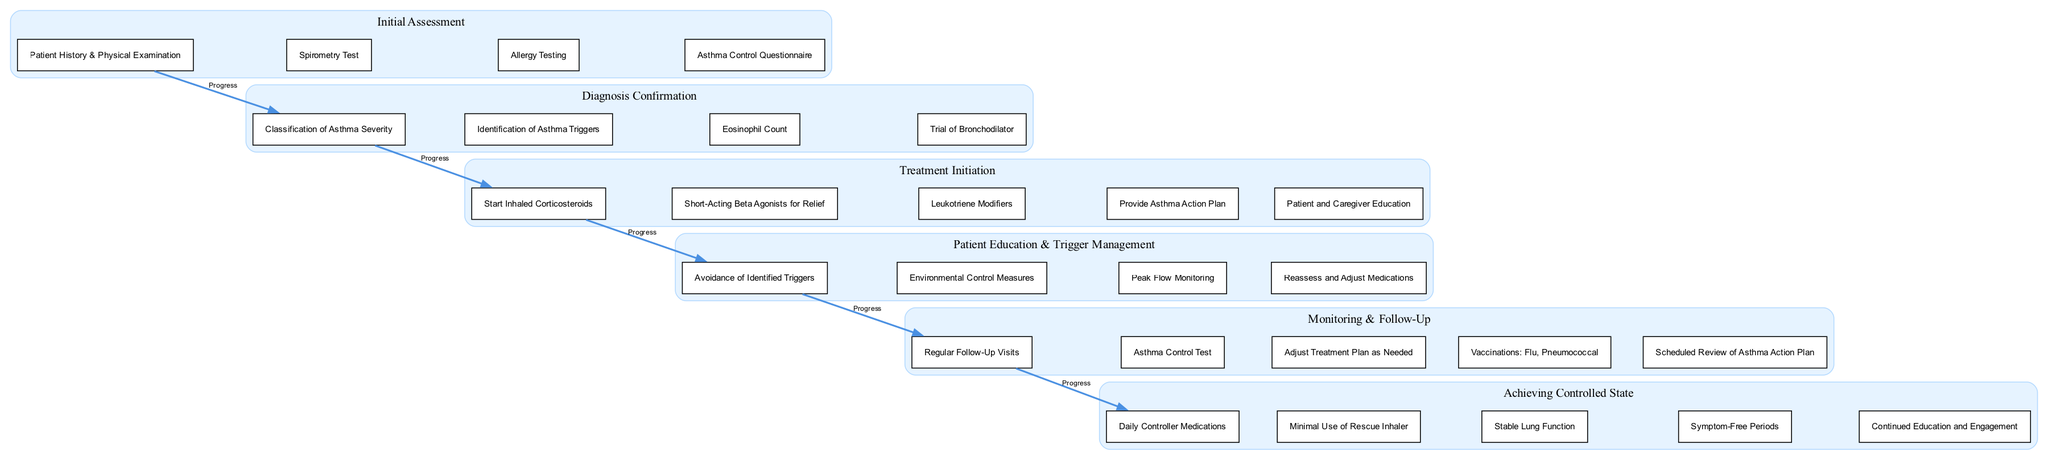What is the first stage of the pathway? The first stage listed in the diagram is "Initial Assessment".
Answer: Initial Assessment How many elements are in the "Treatment Initiation" stage? The "Treatment Initiation" stage contains five elements as indicated in the diagram.
Answer: 5 What is the main focus of the "Patient Education & Trigger Management" stage? The focus of the "Patient Education & Trigger Management" stage is to avoid triggers and control the patient's environment.
Answer: Avoidance of Identified Triggers What connections exist between the stages "Diagnosis Confirmation" and "Treatment Initiation"? There is a direct progression from "Diagnosis Confirmation" to "Treatment Initiation", indicating that after confirming the diagnosis, treatment is initiated.
Answer: Progression What is the last element in the "Achieving Controlled State" stage? The last element listed in the "Achieving Controlled State" stage is "Continued Education and Engagement".
Answer: Continued Education and Engagement Which stage includes "Regular Follow-Up Visits"? "Regular Follow-Up Visits" is included in the "Monitoring & Follow-Up" stage, according to the diagram.
Answer: Monitoring & Follow-Up What type of method is emphasized within "Patient Education & Trigger Management"? The method emphasized is "Environmental Control Measures", which suggests actions to manage the patient's environment effectively.
Answer: Environmental Control Measures How does the diagram categorize asthma severity? The diagram suggests categorization under the "Diagnosis Confirmation" stage through the element "Classification of Asthma Severity".
Answer: Classification of Asthma Severity 